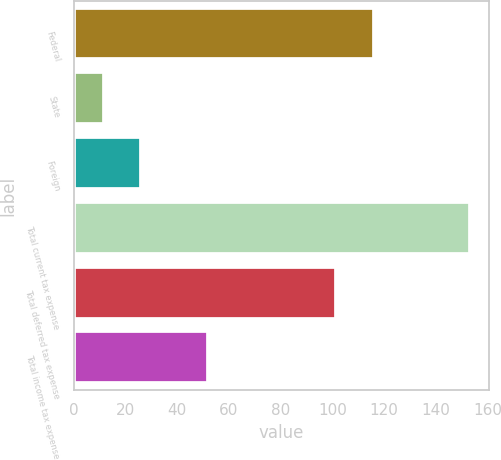Convert chart. <chart><loc_0><loc_0><loc_500><loc_500><bar_chart><fcel>Federal<fcel>State<fcel>Foreign<fcel>Total current tax expense<fcel>Total deferred tax expense<fcel>Total income tax expense<nl><fcel>116.1<fcel>11.8<fcel>25.93<fcel>153.1<fcel>101.3<fcel>51.8<nl></chart> 